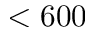<formula> <loc_0><loc_0><loc_500><loc_500>< 6 0 0</formula> 